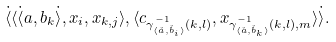<formula> <loc_0><loc_0><loc_500><loc_500>\dot { \langle } \langle \dot { \langle } a , b _ { k } \dot { \rangle } , x _ { i } , x _ { k , j } \rangle , \langle c _ { \gamma _ { \langle \check { a } , \check { b } _ { i } \rangle } ^ { - 1 } ( k , l ) } , x _ { \gamma _ { \langle \check { a } , \check { b } _ { k } \rangle } ^ { - 1 } ( k , l ) , m } \rangle \dot { \rangle } .</formula> 